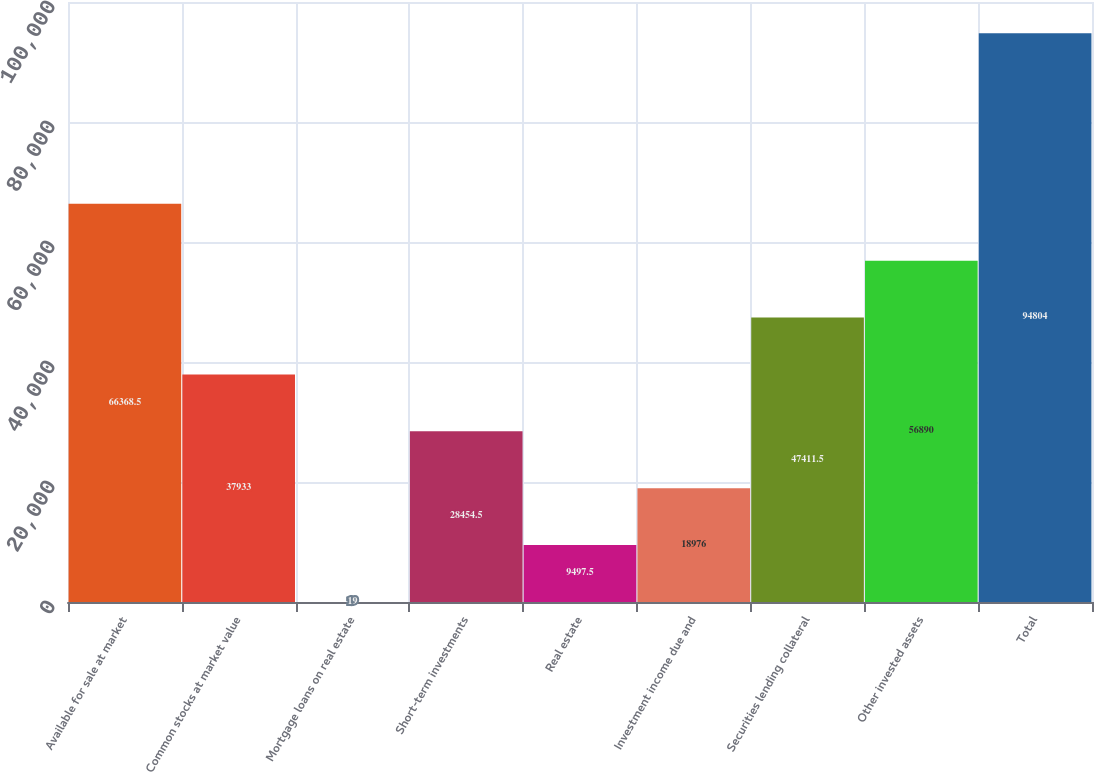Convert chart to OTSL. <chart><loc_0><loc_0><loc_500><loc_500><bar_chart><fcel>Available for sale at market<fcel>Common stocks at market value<fcel>Mortgage loans on real estate<fcel>Short-term investments<fcel>Real estate<fcel>Investment income due and<fcel>Securities lending collateral<fcel>Other invested assets<fcel>Total<nl><fcel>66368.5<fcel>37933<fcel>19<fcel>28454.5<fcel>9497.5<fcel>18976<fcel>47411.5<fcel>56890<fcel>94804<nl></chart> 